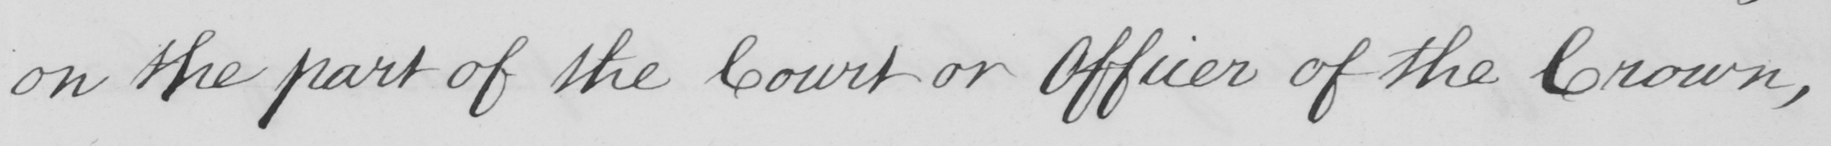Can you read and transcribe this handwriting? on the part of the Court or Officer of the Crown , 